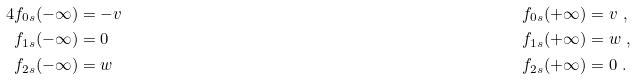Convert formula to latex. <formula><loc_0><loc_0><loc_500><loc_500>4 f _ { 0 s } ( - \infty ) & = - v \quad & f _ { 0 s } ( + \infty ) & = v \ , \\ f _ { 1 s } ( - \infty ) & = 0 \quad & f _ { 1 s } ( + \infty ) & = w \ , \\ f _ { 2 s } ( - \infty ) & = w \quad & f _ { 2 s } ( + \infty ) & = 0 \ .</formula> 